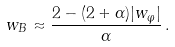Convert formula to latex. <formula><loc_0><loc_0><loc_500><loc_500>w _ { B } \approx \frac { 2 - ( 2 + \alpha ) | w _ { \varphi } | } { \alpha } \, .</formula> 